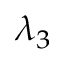<formula> <loc_0><loc_0><loc_500><loc_500>\lambda _ { 3 }</formula> 